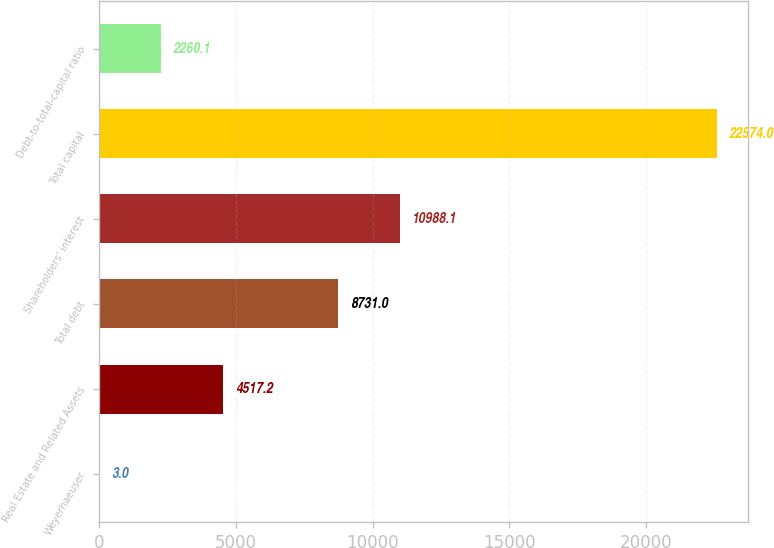Convert chart to OTSL. <chart><loc_0><loc_0><loc_500><loc_500><bar_chart><fcel>Weyerhaeuser<fcel>Real Estate and Related Assets<fcel>Total debt<fcel>Shareholders' interest<fcel>Total capital<fcel>Debt-to-total-capital ratio<nl><fcel>3<fcel>4517.2<fcel>8731<fcel>10988.1<fcel>22574<fcel>2260.1<nl></chart> 